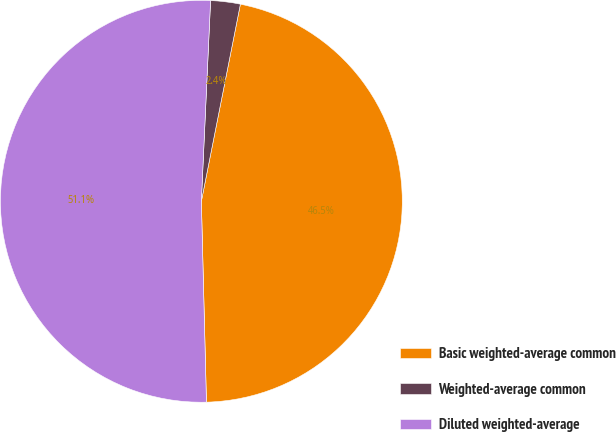<chart> <loc_0><loc_0><loc_500><loc_500><pie_chart><fcel>Basic weighted-average common<fcel>Weighted-average common<fcel>Diluted weighted-average<nl><fcel>46.48%<fcel>2.38%<fcel>51.13%<nl></chart> 